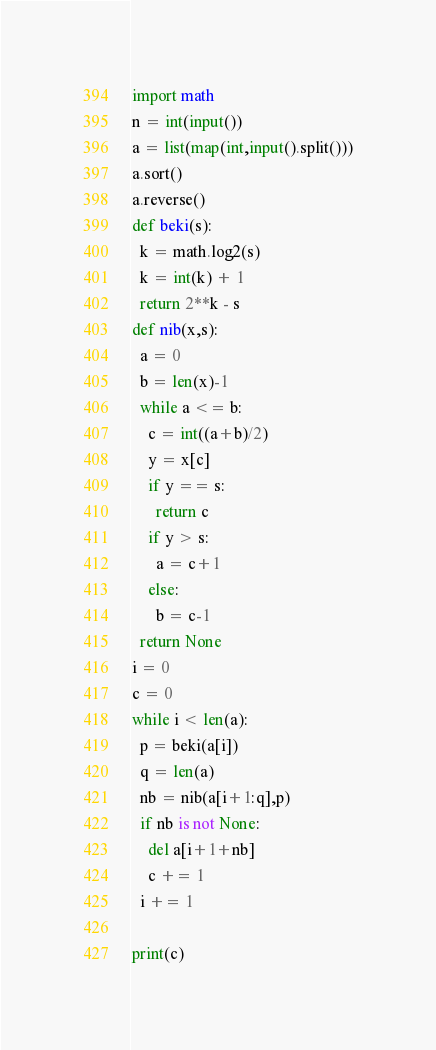<code> <loc_0><loc_0><loc_500><loc_500><_Python_>import math
n = int(input())
a = list(map(int,input().split()))
a.sort()
a.reverse()
def beki(s):
  k = math.log2(s)
  k = int(k) + 1
  return 2**k - s
def nib(x,s):
  a = 0
  b = len(x)-1
  while a <= b:
    c = int((a+b)/2)
    y = x[c]
    if y == s:
      return c
    if y > s:
      a = c+1
    else:
      b = c-1
  return None  
i = 0
c = 0
while i < len(a):
  p = beki(a[i]) 
  q = len(a)
  nb = nib(a[i+1:q],p)
  if nb is not None:
    del a[i+1+nb]
    c += 1
  i += 1
    
print(c)

</code> 